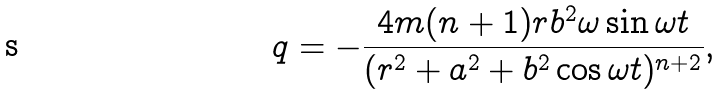<formula> <loc_0><loc_0><loc_500><loc_500>q = - \frac { 4 m ( n + 1 ) r b ^ { 2 } \omega \sin \omega t } { ( r ^ { 2 } + a ^ { 2 } + b ^ { 2 } \cos \omega t ) ^ { n + 2 } } ,</formula> 